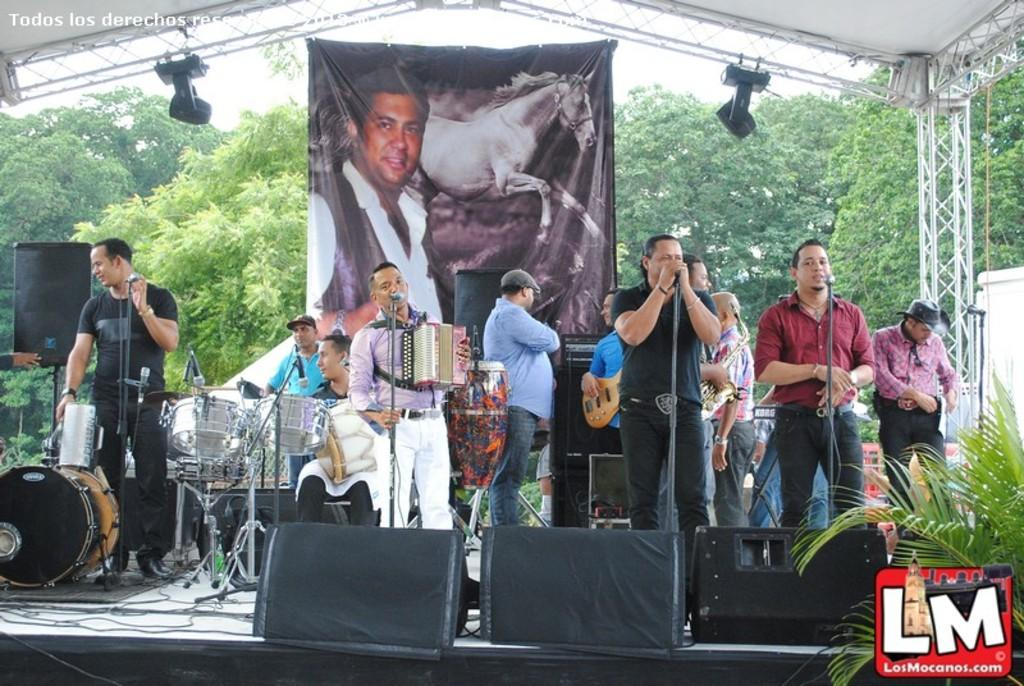How many people are in the image? There is a group of people in the image. What are some of the people in the group doing? Some people in the group are playing a musical instrument. What type of natural element can be seen in the image? There is a tree visible in the image. Can you hear the birds crying in the image? There are no birds or crying sounds present in the image. 